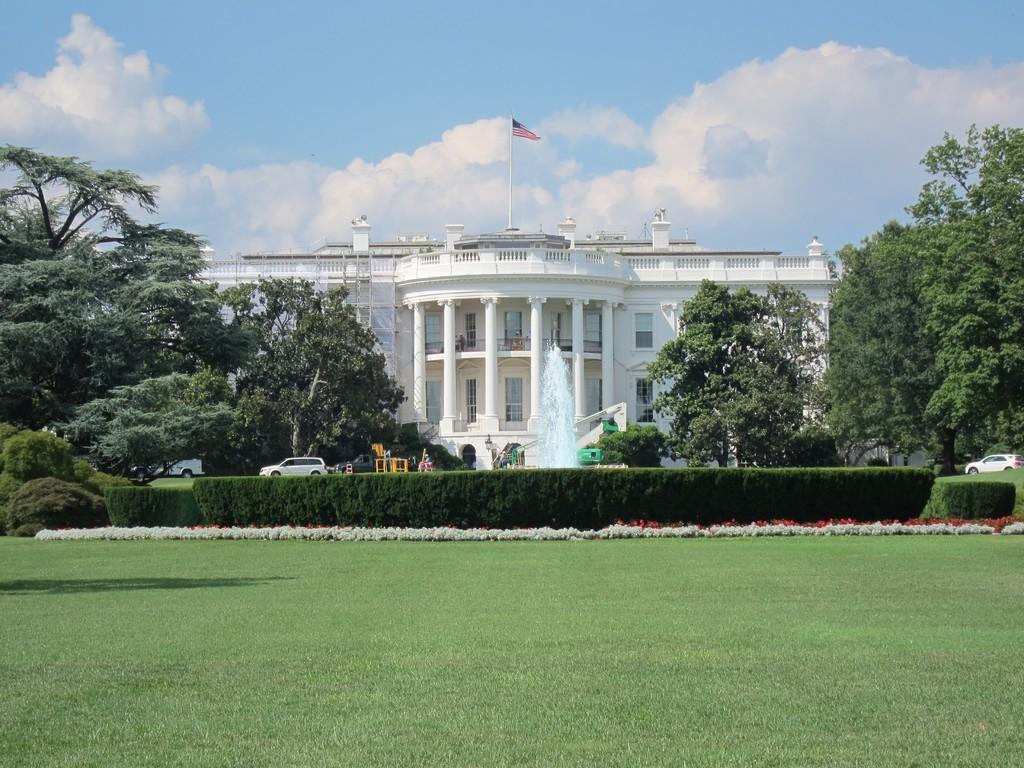Can you describe this image briefly? In this picture we can see grass, vehicles, trees, flag, building with windows, water and in the background we can see the sky with clouds. 